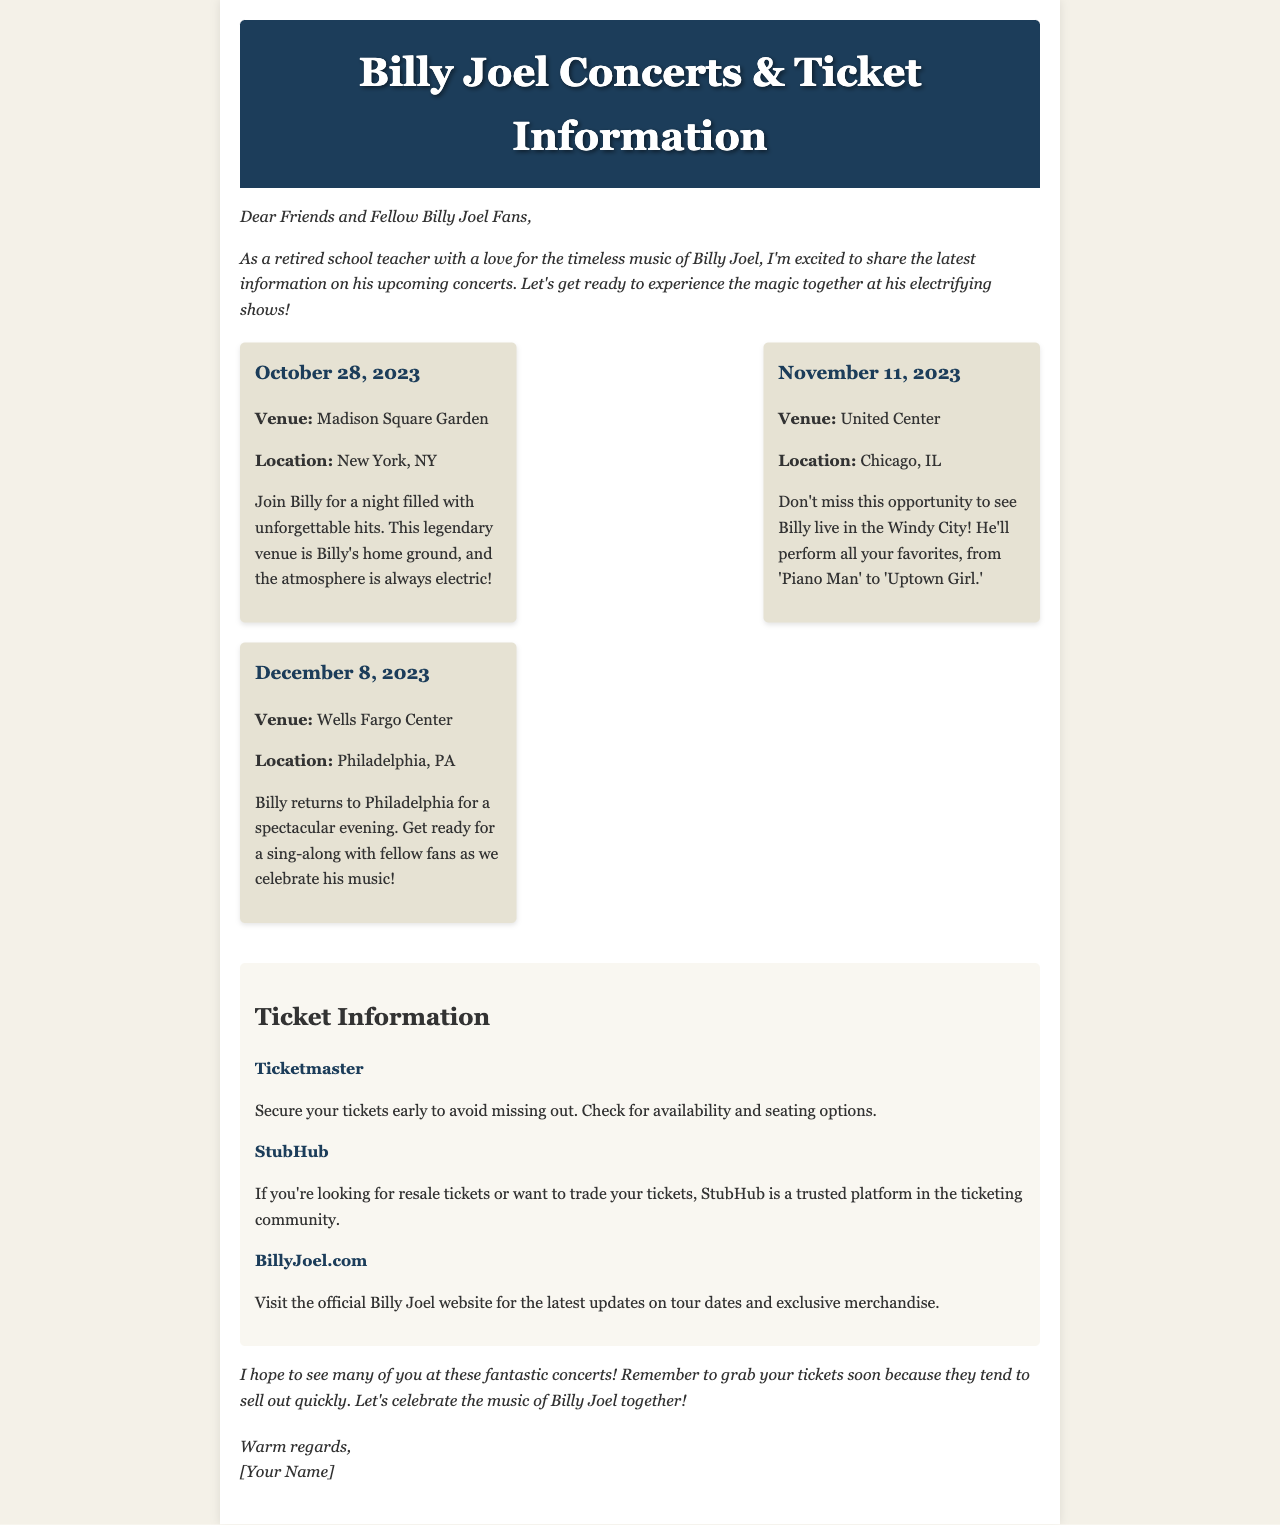What is the date of the concert at Madison Square Garden? The concert at Madison Square Garden is scheduled for October 28, 2023.
Answer: October 28, 2023 What city will Billy Joel perform in on November 11, 2023? On November 11, 2023, Billy Joel will perform in Chicago, IL.
Answer: Chicago, IL Which venue is Billy Joel returning to on December 8, 2023? Billy Joel is returning to the Wells Fargo Center on December 8, 2023.
Answer: Wells Fargo Center What is a suggested platform for securing tickets? A suggested platform for securing tickets is Ticketmaster, as mentioned in the ticket information section.
Answer: Ticketmaster How many concerts are listed in the document? The document lists three upcoming concerts.
Answer: Three Which concert has the description "Get ready for a sing-along with fellow fans"? The concert at the Wells Fargo Center in Philadelphia is described as a sing-along with fellow fans.
Answer: Wells Fargo Center What is the official website for the latest updates on Billy Joel's tour? The official website for the latest updates on Billy Joel's tour is BillyJoel.com.
Answer: BillyJoel.com What should fans do to avoid missing out on tickets? Fans should secure their tickets early to avoid missing out.
Answer: Secure tickets early What is the tone of the introductory paragraph? The tone of the introductory paragraph is enthusiastic and warm, expressing excitement about the upcoming concerts.
Answer: Enthusiastic and warm 